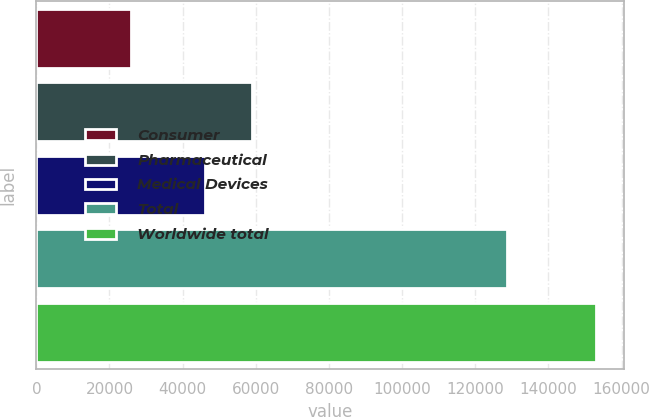Convert chart. <chart><loc_0><loc_0><loc_500><loc_500><bar_chart><fcel>Consumer<fcel>Pharmaceutical<fcel>Medical Devices<fcel>Total<fcel>Worldwide total<nl><fcel>25877<fcel>58961.7<fcel>46254<fcel>128767<fcel>152954<nl></chart> 